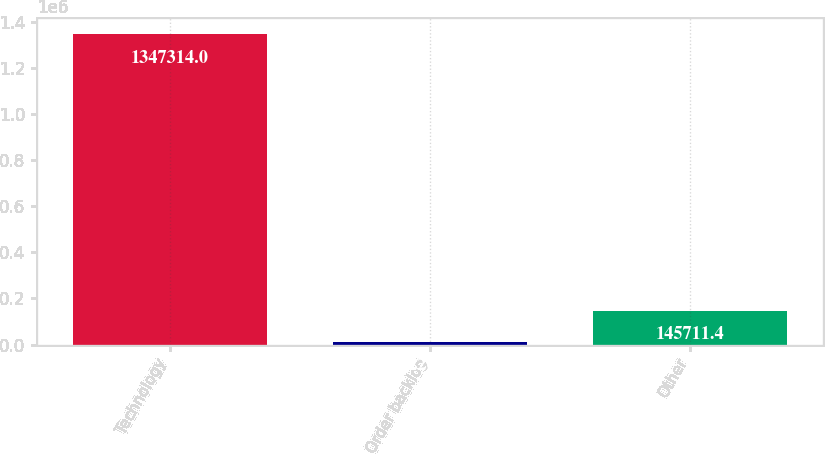Convert chart to OTSL. <chart><loc_0><loc_0><loc_500><loc_500><bar_chart><fcel>Technology<fcel>Order backlog<fcel>Other<nl><fcel>1.34731e+06<fcel>12200<fcel>145711<nl></chart> 